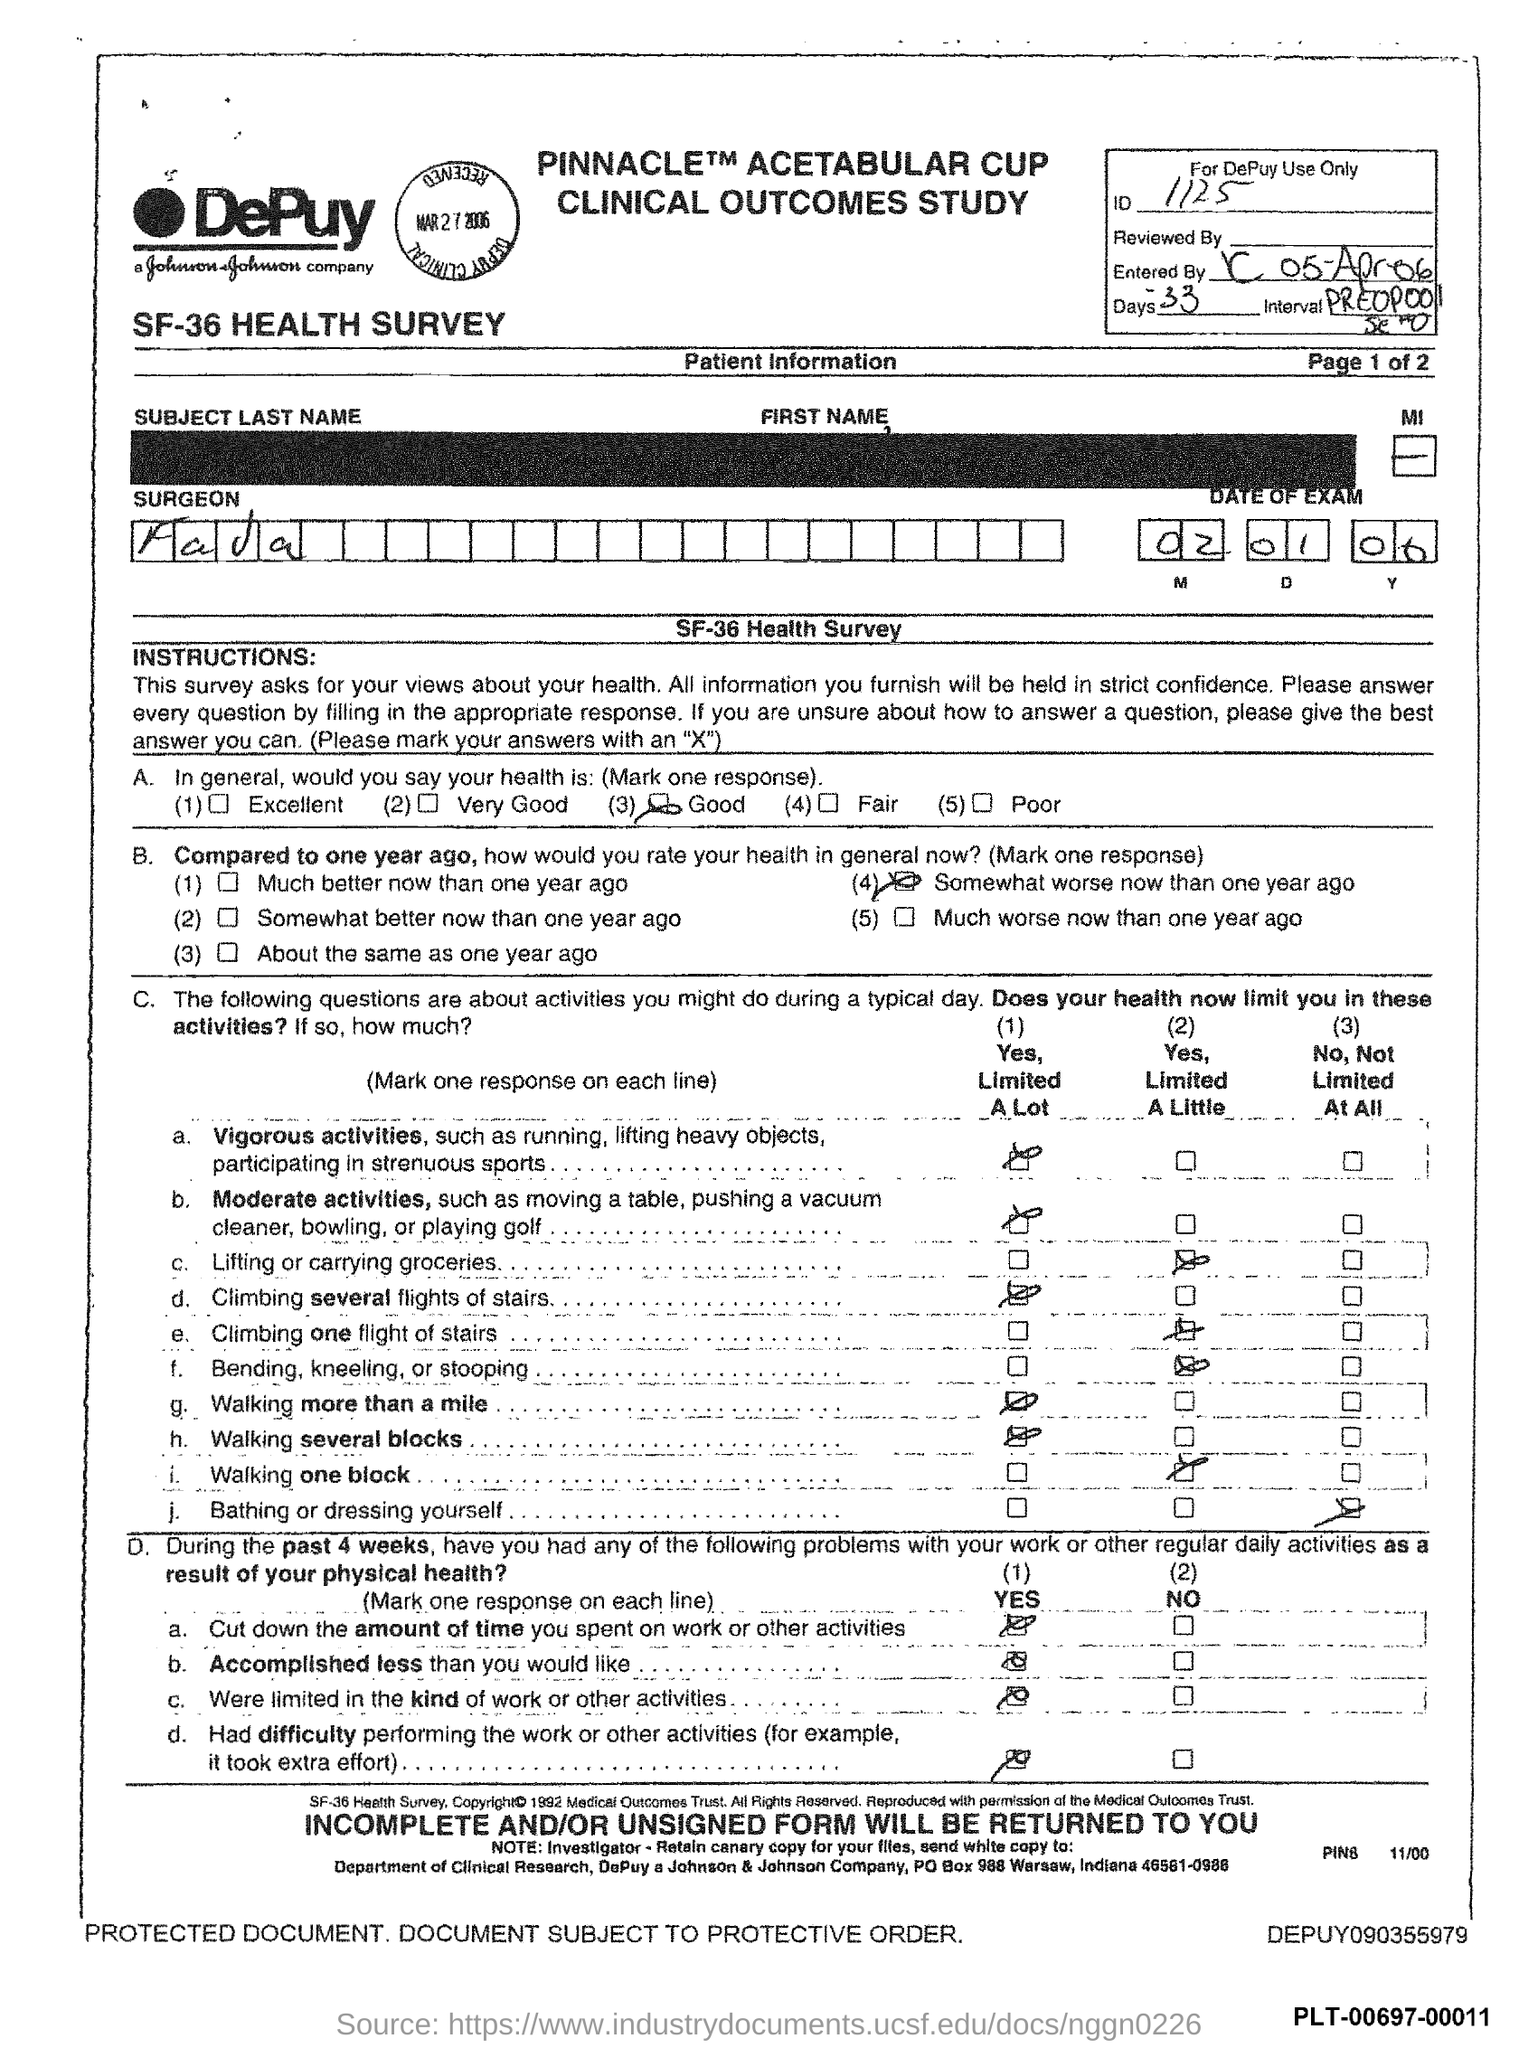What is the date of the exam mentioned in the document?
Provide a short and direct response. 02 01 06. 